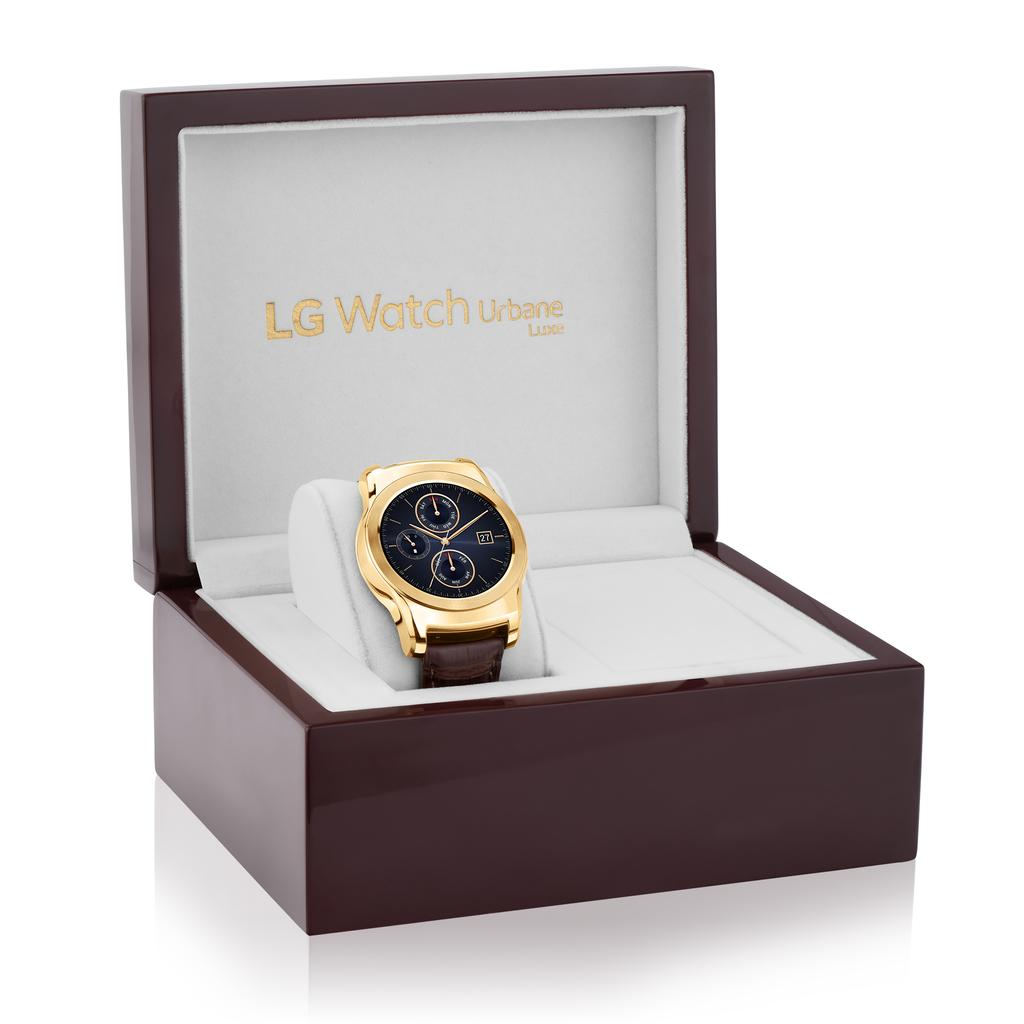<image>
Create a compact narrative representing the image presented. The watch in the box is from the company LG 